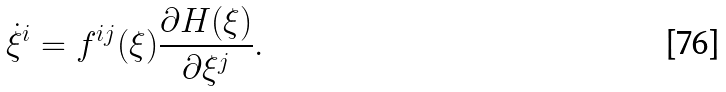<formula> <loc_0><loc_0><loc_500><loc_500>\dot { \xi } ^ { i } = f ^ { i j } ( \xi ) \frac { \partial H ( \xi ) } { \partial \xi ^ { j } } .</formula> 